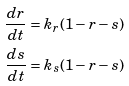<formula> <loc_0><loc_0><loc_500><loc_500>\frac { d r } { d t } = k _ { r } ( 1 - r - s ) \\ \frac { d s } { d t } = k _ { s } ( 1 - r - s )</formula> 